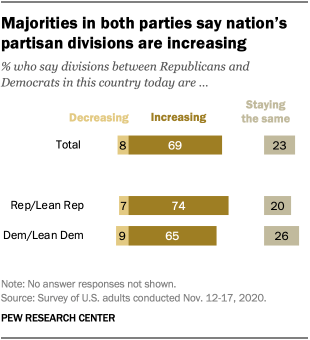Identify some key points in this picture. The median and largest value of a gray bar are 598. The smallest value among the bars is not 8. 